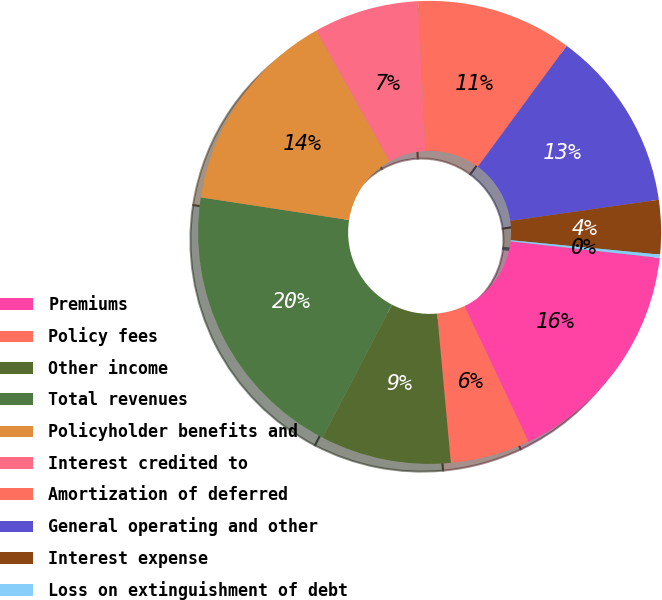Convert chart to OTSL. <chart><loc_0><loc_0><loc_500><loc_500><pie_chart><fcel>Premiums<fcel>Policy fees<fcel>Other income<fcel>Total revenues<fcel>Policyholder benefits and<fcel>Interest credited to<fcel>Amortization of deferred<fcel>General operating and other<fcel>Interest expense<fcel>Loss on extinguishment of debt<nl><fcel>16.22%<fcel>5.56%<fcel>9.11%<fcel>19.77%<fcel>14.44%<fcel>7.34%<fcel>10.89%<fcel>12.66%<fcel>3.78%<fcel>0.23%<nl></chart> 